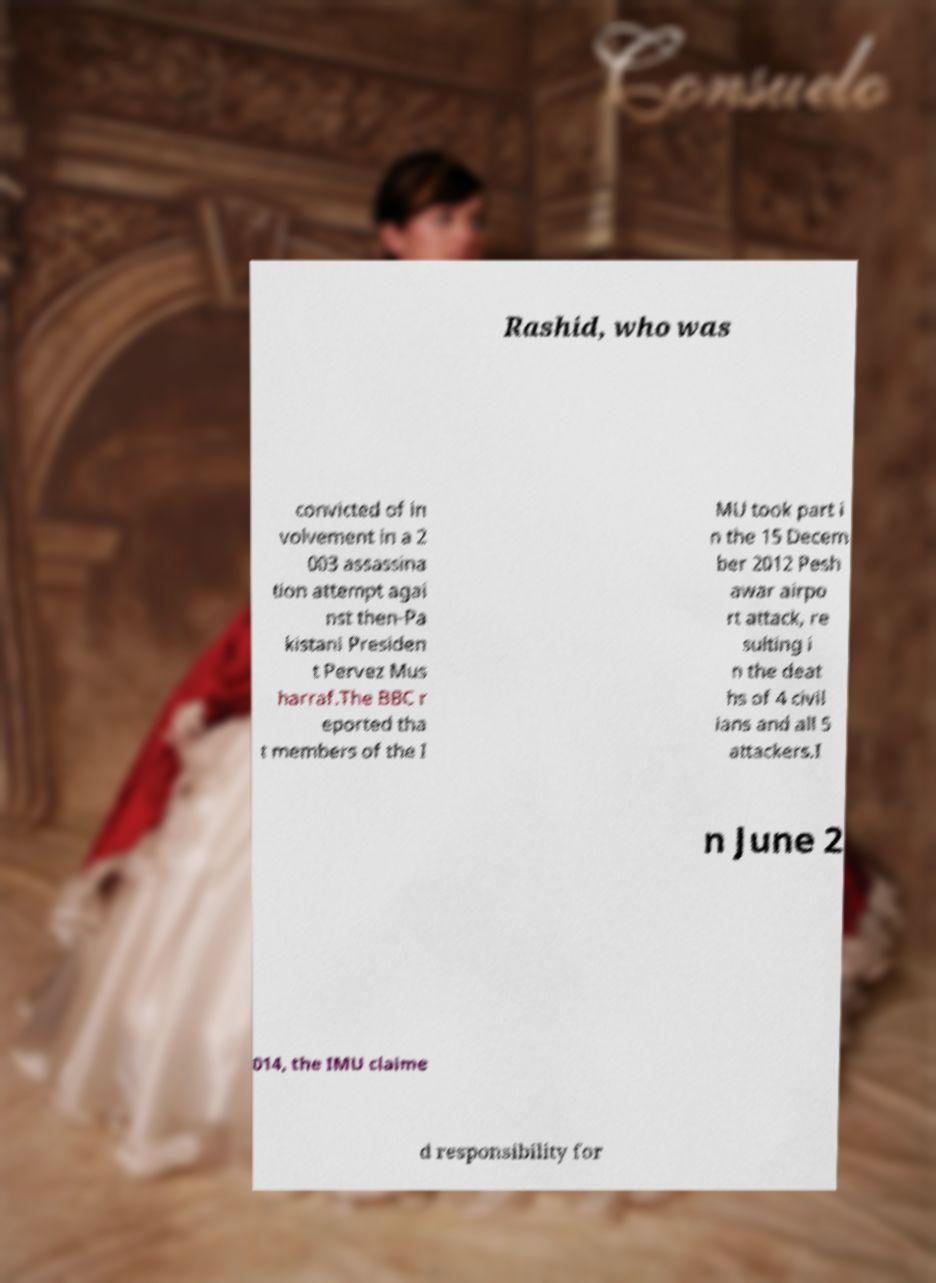Can you accurately transcribe the text from the provided image for me? Rashid, who was convicted of in volvement in a 2 003 assassina tion attempt agai nst then-Pa kistani Presiden t Pervez Mus harraf.The BBC r eported tha t members of the I MU took part i n the 15 Decem ber 2012 Pesh awar airpo rt attack, re sulting i n the deat hs of 4 civil ians and all 5 attackers.I n June 2 014, the IMU claime d responsibility for 